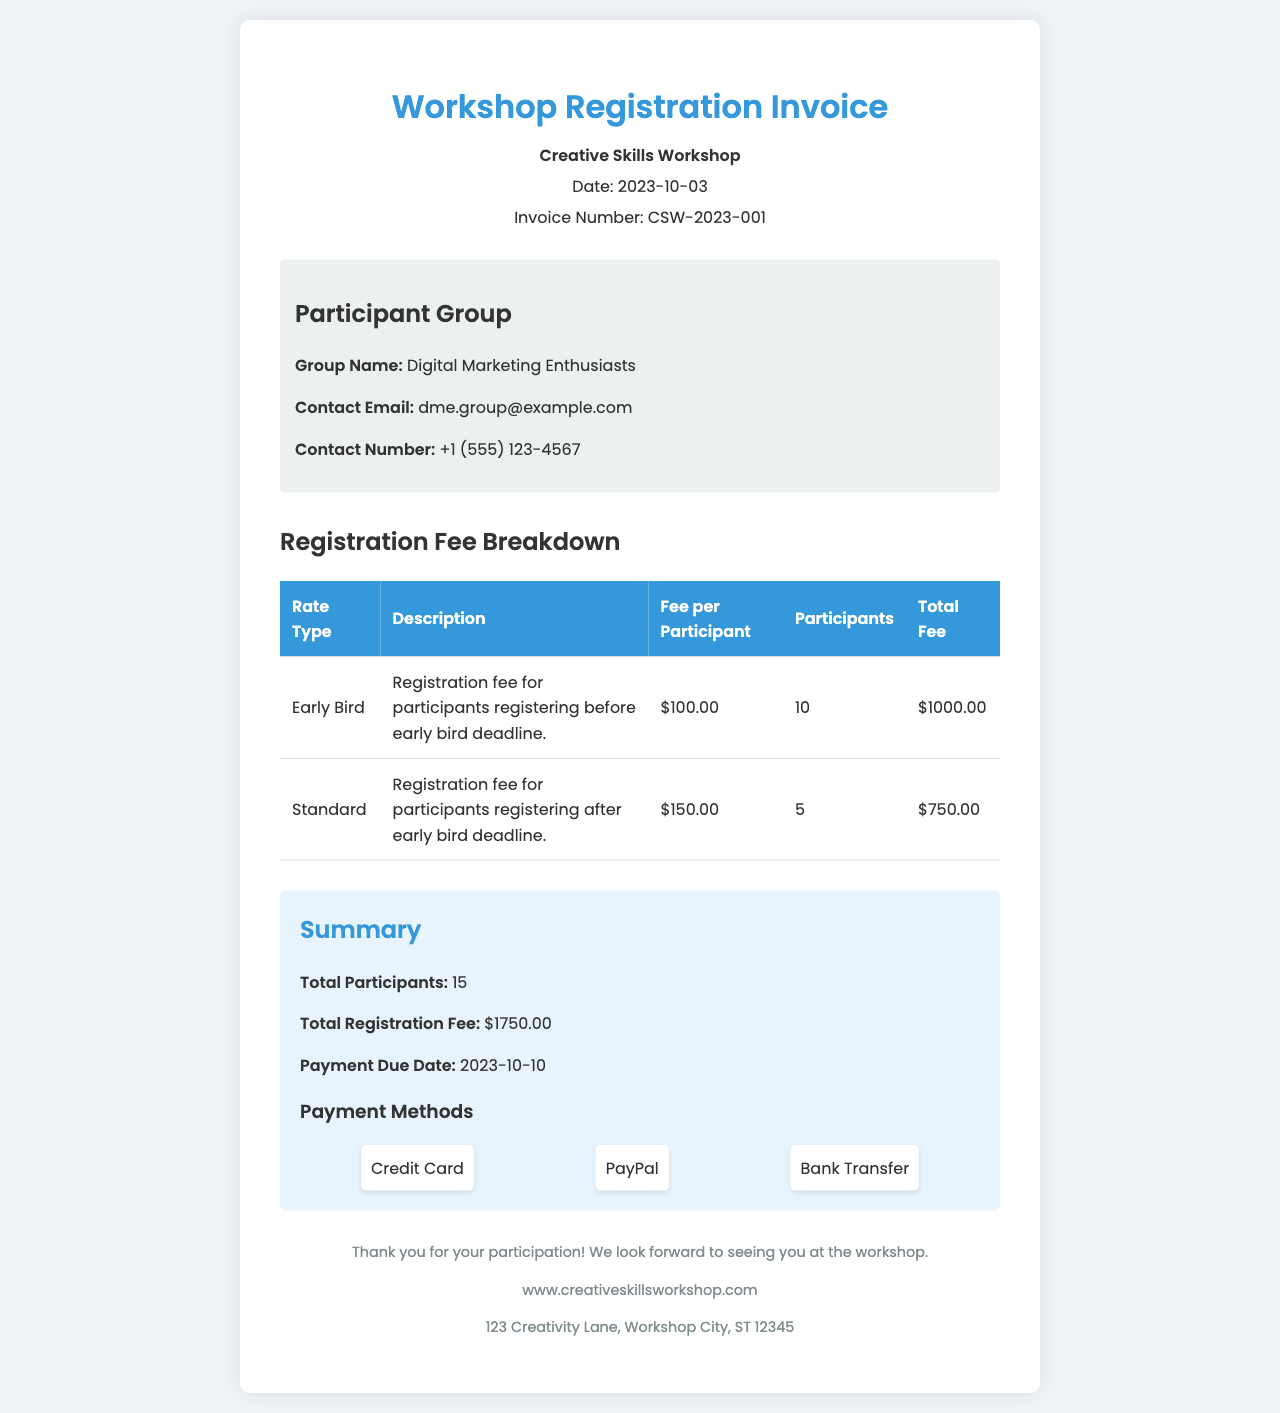What is the total registration fee? The total registration fee is calculated from the sum of the fees for early bird and standard rates. Early Bird: $1000.00 + Standard: $750.00 = $1750.00.
Answer: $1750.00 What is the invoice number? The invoice number is provided in the header section of the document.
Answer: CSW-2023-001 How many participants registered at the early bird rate? The number of participants registering at the early bird rate is specified in the registration fee breakdown table.
Answer: 10 What is the payment due date? The payment due date is mentioned in the summary section of the document.
Answer: 2023-10-10 What is the fee per participant for standard registration? The fee per participant for the standard registration is indicated in the breakdown table.
Answer: $150.00 What is the group name of the participants? The group name is provided in the participant group section of the document.
Answer: Digital Marketing Enthusiasts How many total participants are in the group? The total number of participants is provided in the summary section of the document.
Answer: 15 What is the description for the standard rate? The description for the standard rate is found in the breakdown table.
Answer: Registration fee for participants registering after early bird deadline What are the payment methods listed in the document? The payment methods are displayed in the summary section under payment methods.
Answer: Credit Card, PayPal, Bank Transfer 